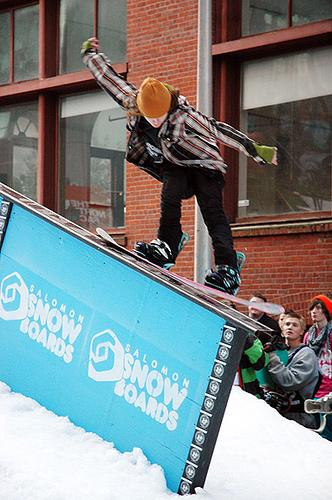What is this wall used for?

Choices:
A) pictures
B) plants
C) snowboarding
D) door snowboarding 